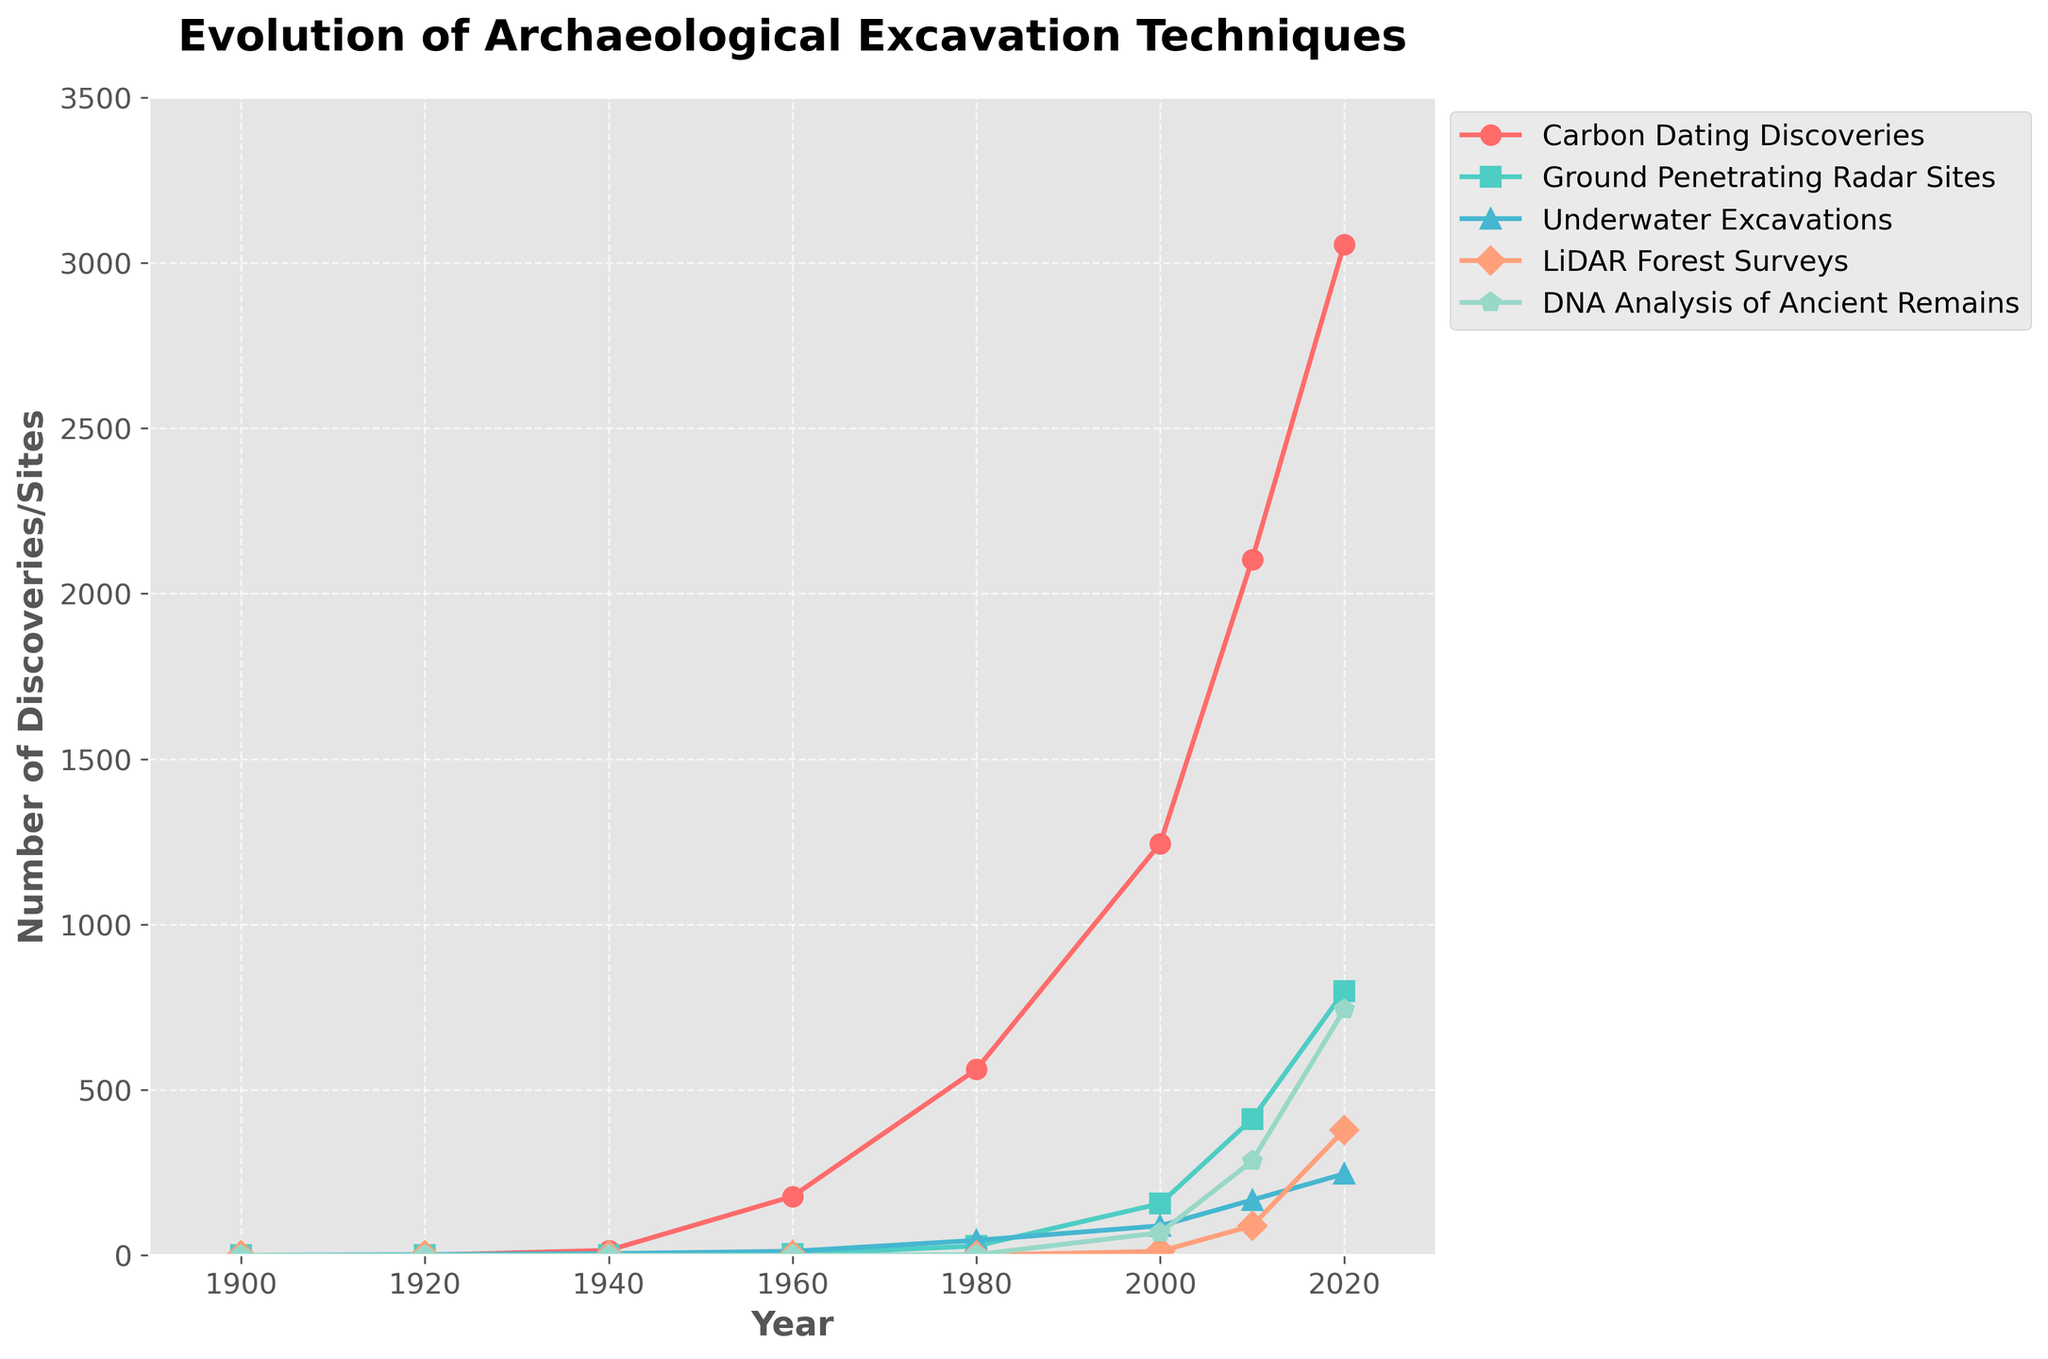Which technique shows the highest number of discoveries/sites in 2020? The data for Carbon Dating Discoveries in 2020 is 3056, Ground Penetrating Radar Sites is 798, Underwater Excavations is 246, LiDAR Forest Surveys is 378, and DNA Analysis of Ancient Remains is 742. Carbon Dating Discoveries has the highest number.
Answer: Carbon Dating Discoveries Between 1900 and 2020, which technique has the fastest growth rate in the number of discoveries/sites? To find the fastest growth, compare the increase between 1900 and 2020 for each technique. Carbon Dating Discoveries increases from 0 to 3056, Ground Penetrating Radar Sites from 0 to 798, Underwater Excavations from 0 to 246, LiDAR Forest Surveys from 0 to 378, and DNA Analysis of Ancient Remains from 0 to 742. The highest increase is for Carbon Dating Discoveries (3056).
Answer: Carbon Dating Discoveries By how many sites did Ground Penetrating Radar Sites increase from 2000 to 2020? The data shows Ground Penetrating Radar Sites with 156 in 2000 and 798 in 2020. The increase is 798 - 156 = 642 sites.
Answer: 642 Which two techniques show the least number of discoveries/sites in 1940? In 1940, the data shows Carbon Dating Discoveries with 15, Ground Penetrating Radar Sites with 0, Underwater Excavations with 5, LiDAR Forest Surveys with 0, and DNA Analysis of Ancient Remains with 0. Ground Penetrating Radar Sites, LiDAR Forest Surveys, and DNA Analysis of Ancient Remains are at 0. Among these, pick two: Ground Penetrating Radar Sites and LiDAR Forest Surveys.
Answer: Ground Penetrating Radar Sites and LiDAR Forest Surveys What is the average number of Carbon Dating Discoveries from 1900 to 2020? Sum the values from 1900 to 2020 for Carbon Dating Discoveries (0 + 0 + 15 + 178 + 562 + 1245 + 2103 + 3056) = 7159. There are 8 data points. The average is 7159 / 8 = 894.875.
Answer: 894.875 Compare the trend of LiDAR Forest Surveys and DNA Analysis of Ancient Remains from 2000 to 2020. Which one shows a steeper increase? In 2000, LiDAR Forest Surveys have 12 and DNA Analysis of Ancient Remains have 68. In 2020, they have 378 and 742, respectively. The increase for LiDAR Forest Surveys is 378 - 12 = 366 and for DNA Analysis of Ancient Remains is 742 - 68 = 674. DNA Analysis of Ancient Remains shows a steeper increase.
Answer: DNA Analysis of Ancient Remains How many Carbon Dating Discoveries were made between 1920 and 1960? Sum the values of Carbon Dating Discoveries in 1920, 1940, and 1960 (0 + 15 + 178) = 193.
Answer: 193 